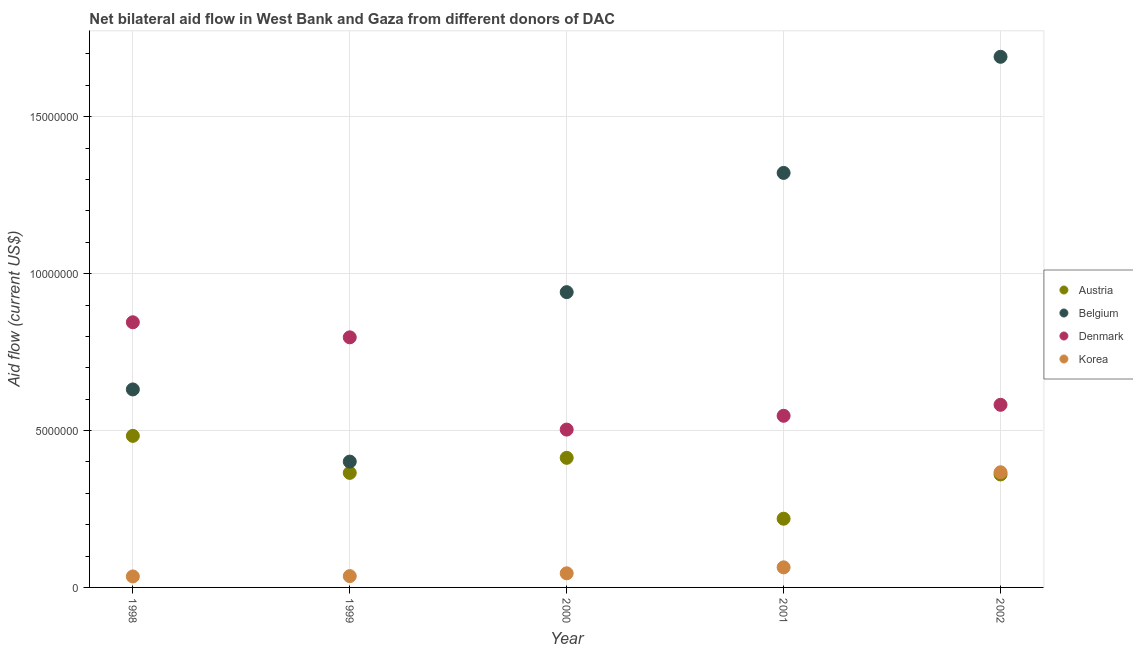How many different coloured dotlines are there?
Keep it short and to the point. 4. What is the amount of aid given by belgium in 2001?
Give a very brief answer. 1.32e+07. Across all years, what is the maximum amount of aid given by belgium?
Provide a short and direct response. 1.69e+07. Across all years, what is the minimum amount of aid given by belgium?
Keep it short and to the point. 4.01e+06. What is the total amount of aid given by korea in the graph?
Provide a succinct answer. 5.47e+06. What is the difference between the amount of aid given by austria in 2000 and that in 2001?
Give a very brief answer. 1.94e+06. What is the difference between the amount of aid given by denmark in 1998 and the amount of aid given by austria in 2000?
Your answer should be compact. 4.32e+06. What is the average amount of aid given by korea per year?
Make the answer very short. 1.09e+06. In the year 2001, what is the difference between the amount of aid given by denmark and amount of aid given by korea?
Your answer should be compact. 4.83e+06. What is the ratio of the amount of aid given by denmark in 2000 to that in 2002?
Ensure brevity in your answer.  0.86. Is the amount of aid given by denmark in 1998 less than that in 2001?
Offer a very short reply. No. What is the difference between the highest and the second highest amount of aid given by belgium?
Your answer should be very brief. 3.70e+06. What is the difference between the highest and the lowest amount of aid given by denmark?
Your answer should be compact. 3.42e+06. In how many years, is the amount of aid given by korea greater than the average amount of aid given by korea taken over all years?
Keep it short and to the point. 1. Is it the case that in every year, the sum of the amount of aid given by austria and amount of aid given by belgium is greater than the amount of aid given by denmark?
Offer a very short reply. No. Does the amount of aid given by denmark monotonically increase over the years?
Your response must be concise. No. Is the amount of aid given by austria strictly less than the amount of aid given by belgium over the years?
Offer a terse response. Yes. How many years are there in the graph?
Offer a terse response. 5. What is the difference between two consecutive major ticks on the Y-axis?
Provide a short and direct response. 5.00e+06. Are the values on the major ticks of Y-axis written in scientific E-notation?
Your answer should be very brief. No. Does the graph contain grids?
Your response must be concise. Yes. How are the legend labels stacked?
Offer a very short reply. Vertical. What is the title of the graph?
Your answer should be compact. Net bilateral aid flow in West Bank and Gaza from different donors of DAC. Does "Argument" appear as one of the legend labels in the graph?
Your answer should be compact. No. What is the Aid flow (current US$) of Austria in 1998?
Give a very brief answer. 4.83e+06. What is the Aid flow (current US$) of Belgium in 1998?
Your answer should be very brief. 6.31e+06. What is the Aid flow (current US$) of Denmark in 1998?
Keep it short and to the point. 8.45e+06. What is the Aid flow (current US$) in Korea in 1998?
Ensure brevity in your answer.  3.50e+05. What is the Aid flow (current US$) of Austria in 1999?
Your answer should be very brief. 3.65e+06. What is the Aid flow (current US$) in Belgium in 1999?
Provide a short and direct response. 4.01e+06. What is the Aid flow (current US$) of Denmark in 1999?
Your answer should be very brief. 7.97e+06. What is the Aid flow (current US$) of Korea in 1999?
Offer a terse response. 3.60e+05. What is the Aid flow (current US$) in Austria in 2000?
Keep it short and to the point. 4.13e+06. What is the Aid flow (current US$) in Belgium in 2000?
Offer a very short reply. 9.41e+06. What is the Aid flow (current US$) in Denmark in 2000?
Provide a succinct answer. 5.03e+06. What is the Aid flow (current US$) in Austria in 2001?
Keep it short and to the point. 2.19e+06. What is the Aid flow (current US$) of Belgium in 2001?
Give a very brief answer. 1.32e+07. What is the Aid flow (current US$) in Denmark in 2001?
Ensure brevity in your answer.  5.47e+06. What is the Aid flow (current US$) in Korea in 2001?
Your answer should be compact. 6.40e+05. What is the Aid flow (current US$) in Austria in 2002?
Make the answer very short. 3.60e+06. What is the Aid flow (current US$) in Belgium in 2002?
Your response must be concise. 1.69e+07. What is the Aid flow (current US$) of Denmark in 2002?
Your answer should be very brief. 5.82e+06. What is the Aid flow (current US$) of Korea in 2002?
Your answer should be compact. 3.67e+06. Across all years, what is the maximum Aid flow (current US$) of Austria?
Make the answer very short. 4.83e+06. Across all years, what is the maximum Aid flow (current US$) in Belgium?
Keep it short and to the point. 1.69e+07. Across all years, what is the maximum Aid flow (current US$) in Denmark?
Provide a short and direct response. 8.45e+06. Across all years, what is the maximum Aid flow (current US$) of Korea?
Keep it short and to the point. 3.67e+06. Across all years, what is the minimum Aid flow (current US$) in Austria?
Your response must be concise. 2.19e+06. Across all years, what is the minimum Aid flow (current US$) in Belgium?
Provide a short and direct response. 4.01e+06. Across all years, what is the minimum Aid flow (current US$) in Denmark?
Make the answer very short. 5.03e+06. What is the total Aid flow (current US$) in Austria in the graph?
Your answer should be very brief. 1.84e+07. What is the total Aid flow (current US$) of Belgium in the graph?
Your response must be concise. 4.98e+07. What is the total Aid flow (current US$) in Denmark in the graph?
Provide a succinct answer. 3.27e+07. What is the total Aid flow (current US$) in Korea in the graph?
Offer a terse response. 5.47e+06. What is the difference between the Aid flow (current US$) in Austria in 1998 and that in 1999?
Your response must be concise. 1.18e+06. What is the difference between the Aid flow (current US$) of Belgium in 1998 and that in 1999?
Your answer should be compact. 2.30e+06. What is the difference between the Aid flow (current US$) of Korea in 1998 and that in 1999?
Your answer should be compact. -10000. What is the difference between the Aid flow (current US$) in Belgium in 1998 and that in 2000?
Give a very brief answer. -3.10e+06. What is the difference between the Aid flow (current US$) of Denmark in 1998 and that in 2000?
Give a very brief answer. 3.42e+06. What is the difference between the Aid flow (current US$) of Korea in 1998 and that in 2000?
Your answer should be compact. -1.00e+05. What is the difference between the Aid flow (current US$) in Austria in 1998 and that in 2001?
Make the answer very short. 2.64e+06. What is the difference between the Aid flow (current US$) of Belgium in 1998 and that in 2001?
Offer a terse response. -6.90e+06. What is the difference between the Aid flow (current US$) of Denmark in 1998 and that in 2001?
Make the answer very short. 2.98e+06. What is the difference between the Aid flow (current US$) in Korea in 1998 and that in 2001?
Give a very brief answer. -2.90e+05. What is the difference between the Aid flow (current US$) of Austria in 1998 and that in 2002?
Offer a very short reply. 1.23e+06. What is the difference between the Aid flow (current US$) in Belgium in 1998 and that in 2002?
Your answer should be compact. -1.06e+07. What is the difference between the Aid flow (current US$) in Denmark in 1998 and that in 2002?
Keep it short and to the point. 2.63e+06. What is the difference between the Aid flow (current US$) in Korea in 1998 and that in 2002?
Your response must be concise. -3.32e+06. What is the difference between the Aid flow (current US$) of Austria in 1999 and that in 2000?
Your response must be concise. -4.80e+05. What is the difference between the Aid flow (current US$) in Belgium in 1999 and that in 2000?
Make the answer very short. -5.40e+06. What is the difference between the Aid flow (current US$) of Denmark in 1999 and that in 2000?
Your answer should be very brief. 2.94e+06. What is the difference between the Aid flow (current US$) in Austria in 1999 and that in 2001?
Make the answer very short. 1.46e+06. What is the difference between the Aid flow (current US$) of Belgium in 1999 and that in 2001?
Ensure brevity in your answer.  -9.20e+06. What is the difference between the Aid flow (current US$) in Denmark in 1999 and that in 2001?
Provide a short and direct response. 2.50e+06. What is the difference between the Aid flow (current US$) of Korea in 1999 and that in 2001?
Your answer should be very brief. -2.80e+05. What is the difference between the Aid flow (current US$) of Austria in 1999 and that in 2002?
Ensure brevity in your answer.  5.00e+04. What is the difference between the Aid flow (current US$) in Belgium in 1999 and that in 2002?
Your response must be concise. -1.29e+07. What is the difference between the Aid flow (current US$) of Denmark in 1999 and that in 2002?
Provide a succinct answer. 2.15e+06. What is the difference between the Aid flow (current US$) of Korea in 1999 and that in 2002?
Make the answer very short. -3.31e+06. What is the difference between the Aid flow (current US$) of Austria in 2000 and that in 2001?
Give a very brief answer. 1.94e+06. What is the difference between the Aid flow (current US$) of Belgium in 2000 and that in 2001?
Your answer should be very brief. -3.80e+06. What is the difference between the Aid flow (current US$) in Denmark in 2000 and that in 2001?
Give a very brief answer. -4.40e+05. What is the difference between the Aid flow (current US$) of Austria in 2000 and that in 2002?
Give a very brief answer. 5.30e+05. What is the difference between the Aid flow (current US$) in Belgium in 2000 and that in 2002?
Give a very brief answer. -7.50e+06. What is the difference between the Aid flow (current US$) in Denmark in 2000 and that in 2002?
Your answer should be compact. -7.90e+05. What is the difference between the Aid flow (current US$) in Korea in 2000 and that in 2002?
Your answer should be very brief. -3.22e+06. What is the difference between the Aid flow (current US$) in Austria in 2001 and that in 2002?
Give a very brief answer. -1.41e+06. What is the difference between the Aid flow (current US$) in Belgium in 2001 and that in 2002?
Your response must be concise. -3.70e+06. What is the difference between the Aid flow (current US$) of Denmark in 2001 and that in 2002?
Your answer should be very brief. -3.50e+05. What is the difference between the Aid flow (current US$) of Korea in 2001 and that in 2002?
Keep it short and to the point. -3.03e+06. What is the difference between the Aid flow (current US$) in Austria in 1998 and the Aid flow (current US$) in Belgium in 1999?
Ensure brevity in your answer.  8.20e+05. What is the difference between the Aid flow (current US$) in Austria in 1998 and the Aid flow (current US$) in Denmark in 1999?
Offer a terse response. -3.14e+06. What is the difference between the Aid flow (current US$) of Austria in 1998 and the Aid flow (current US$) of Korea in 1999?
Ensure brevity in your answer.  4.47e+06. What is the difference between the Aid flow (current US$) in Belgium in 1998 and the Aid flow (current US$) in Denmark in 1999?
Ensure brevity in your answer.  -1.66e+06. What is the difference between the Aid flow (current US$) in Belgium in 1998 and the Aid flow (current US$) in Korea in 1999?
Offer a very short reply. 5.95e+06. What is the difference between the Aid flow (current US$) in Denmark in 1998 and the Aid flow (current US$) in Korea in 1999?
Offer a terse response. 8.09e+06. What is the difference between the Aid flow (current US$) in Austria in 1998 and the Aid flow (current US$) in Belgium in 2000?
Give a very brief answer. -4.58e+06. What is the difference between the Aid flow (current US$) of Austria in 1998 and the Aid flow (current US$) of Korea in 2000?
Provide a short and direct response. 4.38e+06. What is the difference between the Aid flow (current US$) in Belgium in 1998 and the Aid flow (current US$) in Denmark in 2000?
Offer a very short reply. 1.28e+06. What is the difference between the Aid flow (current US$) in Belgium in 1998 and the Aid flow (current US$) in Korea in 2000?
Give a very brief answer. 5.86e+06. What is the difference between the Aid flow (current US$) in Denmark in 1998 and the Aid flow (current US$) in Korea in 2000?
Make the answer very short. 8.00e+06. What is the difference between the Aid flow (current US$) of Austria in 1998 and the Aid flow (current US$) of Belgium in 2001?
Your answer should be very brief. -8.38e+06. What is the difference between the Aid flow (current US$) in Austria in 1998 and the Aid flow (current US$) in Denmark in 2001?
Your response must be concise. -6.40e+05. What is the difference between the Aid flow (current US$) in Austria in 1998 and the Aid flow (current US$) in Korea in 2001?
Make the answer very short. 4.19e+06. What is the difference between the Aid flow (current US$) of Belgium in 1998 and the Aid flow (current US$) of Denmark in 2001?
Your answer should be compact. 8.40e+05. What is the difference between the Aid flow (current US$) of Belgium in 1998 and the Aid flow (current US$) of Korea in 2001?
Your answer should be very brief. 5.67e+06. What is the difference between the Aid flow (current US$) in Denmark in 1998 and the Aid flow (current US$) in Korea in 2001?
Give a very brief answer. 7.81e+06. What is the difference between the Aid flow (current US$) of Austria in 1998 and the Aid flow (current US$) of Belgium in 2002?
Provide a succinct answer. -1.21e+07. What is the difference between the Aid flow (current US$) of Austria in 1998 and the Aid flow (current US$) of Denmark in 2002?
Offer a very short reply. -9.90e+05. What is the difference between the Aid flow (current US$) of Austria in 1998 and the Aid flow (current US$) of Korea in 2002?
Keep it short and to the point. 1.16e+06. What is the difference between the Aid flow (current US$) in Belgium in 1998 and the Aid flow (current US$) in Korea in 2002?
Your answer should be compact. 2.64e+06. What is the difference between the Aid flow (current US$) of Denmark in 1998 and the Aid flow (current US$) of Korea in 2002?
Your answer should be very brief. 4.78e+06. What is the difference between the Aid flow (current US$) of Austria in 1999 and the Aid flow (current US$) of Belgium in 2000?
Give a very brief answer. -5.76e+06. What is the difference between the Aid flow (current US$) of Austria in 1999 and the Aid flow (current US$) of Denmark in 2000?
Keep it short and to the point. -1.38e+06. What is the difference between the Aid flow (current US$) of Austria in 1999 and the Aid flow (current US$) of Korea in 2000?
Your answer should be very brief. 3.20e+06. What is the difference between the Aid flow (current US$) of Belgium in 1999 and the Aid flow (current US$) of Denmark in 2000?
Offer a terse response. -1.02e+06. What is the difference between the Aid flow (current US$) in Belgium in 1999 and the Aid flow (current US$) in Korea in 2000?
Keep it short and to the point. 3.56e+06. What is the difference between the Aid flow (current US$) in Denmark in 1999 and the Aid flow (current US$) in Korea in 2000?
Ensure brevity in your answer.  7.52e+06. What is the difference between the Aid flow (current US$) of Austria in 1999 and the Aid flow (current US$) of Belgium in 2001?
Provide a succinct answer. -9.56e+06. What is the difference between the Aid flow (current US$) in Austria in 1999 and the Aid flow (current US$) in Denmark in 2001?
Give a very brief answer. -1.82e+06. What is the difference between the Aid flow (current US$) in Austria in 1999 and the Aid flow (current US$) in Korea in 2001?
Your response must be concise. 3.01e+06. What is the difference between the Aid flow (current US$) in Belgium in 1999 and the Aid flow (current US$) in Denmark in 2001?
Keep it short and to the point. -1.46e+06. What is the difference between the Aid flow (current US$) in Belgium in 1999 and the Aid flow (current US$) in Korea in 2001?
Ensure brevity in your answer.  3.37e+06. What is the difference between the Aid flow (current US$) in Denmark in 1999 and the Aid flow (current US$) in Korea in 2001?
Ensure brevity in your answer.  7.33e+06. What is the difference between the Aid flow (current US$) of Austria in 1999 and the Aid flow (current US$) of Belgium in 2002?
Give a very brief answer. -1.33e+07. What is the difference between the Aid flow (current US$) of Austria in 1999 and the Aid flow (current US$) of Denmark in 2002?
Your response must be concise. -2.17e+06. What is the difference between the Aid flow (current US$) in Austria in 1999 and the Aid flow (current US$) in Korea in 2002?
Provide a succinct answer. -2.00e+04. What is the difference between the Aid flow (current US$) of Belgium in 1999 and the Aid flow (current US$) of Denmark in 2002?
Keep it short and to the point. -1.81e+06. What is the difference between the Aid flow (current US$) in Denmark in 1999 and the Aid flow (current US$) in Korea in 2002?
Give a very brief answer. 4.30e+06. What is the difference between the Aid flow (current US$) in Austria in 2000 and the Aid flow (current US$) in Belgium in 2001?
Ensure brevity in your answer.  -9.08e+06. What is the difference between the Aid flow (current US$) in Austria in 2000 and the Aid flow (current US$) in Denmark in 2001?
Your response must be concise. -1.34e+06. What is the difference between the Aid flow (current US$) in Austria in 2000 and the Aid flow (current US$) in Korea in 2001?
Give a very brief answer. 3.49e+06. What is the difference between the Aid flow (current US$) of Belgium in 2000 and the Aid flow (current US$) of Denmark in 2001?
Make the answer very short. 3.94e+06. What is the difference between the Aid flow (current US$) of Belgium in 2000 and the Aid flow (current US$) of Korea in 2001?
Keep it short and to the point. 8.77e+06. What is the difference between the Aid flow (current US$) of Denmark in 2000 and the Aid flow (current US$) of Korea in 2001?
Make the answer very short. 4.39e+06. What is the difference between the Aid flow (current US$) in Austria in 2000 and the Aid flow (current US$) in Belgium in 2002?
Make the answer very short. -1.28e+07. What is the difference between the Aid flow (current US$) of Austria in 2000 and the Aid flow (current US$) of Denmark in 2002?
Your answer should be very brief. -1.69e+06. What is the difference between the Aid flow (current US$) of Austria in 2000 and the Aid flow (current US$) of Korea in 2002?
Your answer should be compact. 4.60e+05. What is the difference between the Aid flow (current US$) in Belgium in 2000 and the Aid flow (current US$) in Denmark in 2002?
Provide a succinct answer. 3.59e+06. What is the difference between the Aid flow (current US$) of Belgium in 2000 and the Aid flow (current US$) of Korea in 2002?
Provide a short and direct response. 5.74e+06. What is the difference between the Aid flow (current US$) in Denmark in 2000 and the Aid flow (current US$) in Korea in 2002?
Make the answer very short. 1.36e+06. What is the difference between the Aid flow (current US$) in Austria in 2001 and the Aid flow (current US$) in Belgium in 2002?
Your answer should be very brief. -1.47e+07. What is the difference between the Aid flow (current US$) of Austria in 2001 and the Aid flow (current US$) of Denmark in 2002?
Offer a terse response. -3.63e+06. What is the difference between the Aid flow (current US$) of Austria in 2001 and the Aid flow (current US$) of Korea in 2002?
Provide a succinct answer. -1.48e+06. What is the difference between the Aid flow (current US$) in Belgium in 2001 and the Aid flow (current US$) in Denmark in 2002?
Make the answer very short. 7.39e+06. What is the difference between the Aid flow (current US$) of Belgium in 2001 and the Aid flow (current US$) of Korea in 2002?
Your answer should be very brief. 9.54e+06. What is the difference between the Aid flow (current US$) in Denmark in 2001 and the Aid flow (current US$) in Korea in 2002?
Make the answer very short. 1.80e+06. What is the average Aid flow (current US$) of Austria per year?
Your answer should be very brief. 3.68e+06. What is the average Aid flow (current US$) of Belgium per year?
Your answer should be very brief. 9.97e+06. What is the average Aid flow (current US$) of Denmark per year?
Your answer should be compact. 6.55e+06. What is the average Aid flow (current US$) of Korea per year?
Offer a terse response. 1.09e+06. In the year 1998, what is the difference between the Aid flow (current US$) of Austria and Aid flow (current US$) of Belgium?
Your answer should be very brief. -1.48e+06. In the year 1998, what is the difference between the Aid flow (current US$) in Austria and Aid flow (current US$) in Denmark?
Offer a very short reply. -3.62e+06. In the year 1998, what is the difference between the Aid flow (current US$) in Austria and Aid flow (current US$) in Korea?
Make the answer very short. 4.48e+06. In the year 1998, what is the difference between the Aid flow (current US$) of Belgium and Aid flow (current US$) of Denmark?
Provide a succinct answer. -2.14e+06. In the year 1998, what is the difference between the Aid flow (current US$) of Belgium and Aid flow (current US$) of Korea?
Ensure brevity in your answer.  5.96e+06. In the year 1998, what is the difference between the Aid flow (current US$) in Denmark and Aid flow (current US$) in Korea?
Ensure brevity in your answer.  8.10e+06. In the year 1999, what is the difference between the Aid flow (current US$) in Austria and Aid flow (current US$) in Belgium?
Offer a very short reply. -3.60e+05. In the year 1999, what is the difference between the Aid flow (current US$) in Austria and Aid flow (current US$) in Denmark?
Give a very brief answer. -4.32e+06. In the year 1999, what is the difference between the Aid flow (current US$) in Austria and Aid flow (current US$) in Korea?
Make the answer very short. 3.29e+06. In the year 1999, what is the difference between the Aid flow (current US$) in Belgium and Aid flow (current US$) in Denmark?
Ensure brevity in your answer.  -3.96e+06. In the year 1999, what is the difference between the Aid flow (current US$) in Belgium and Aid flow (current US$) in Korea?
Your answer should be compact. 3.65e+06. In the year 1999, what is the difference between the Aid flow (current US$) of Denmark and Aid flow (current US$) of Korea?
Ensure brevity in your answer.  7.61e+06. In the year 2000, what is the difference between the Aid flow (current US$) of Austria and Aid flow (current US$) of Belgium?
Ensure brevity in your answer.  -5.28e+06. In the year 2000, what is the difference between the Aid flow (current US$) in Austria and Aid flow (current US$) in Denmark?
Provide a short and direct response. -9.00e+05. In the year 2000, what is the difference between the Aid flow (current US$) of Austria and Aid flow (current US$) of Korea?
Ensure brevity in your answer.  3.68e+06. In the year 2000, what is the difference between the Aid flow (current US$) in Belgium and Aid flow (current US$) in Denmark?
Provide a short and direct response. 4.38e+06. In the year 2000, what is the difference between the Aid flow (current US$) of Belgium and Aid flow (current US$) of Korea?
Keep it short and to the point. 8.96e+06. In the year 2000, what is the difference between the Aid flow (current US$) in Denmark and Aid flow (current US$) in Korea?
Make the answer very short. 4.58e+06. In the year 2001, what is the difference between the Aid flow (current US$) in Austria and Aid flow (current US$) in Belgium?
Give a very brief answer. -1.10e+07. In the year 2001, what is the difference between the Aid flow (current US$) of Austria and Aid flow (current US$) of Denmark?
Your response must be concise. -3.28e+06. In the year 2001, what is the difference between the Aid flow (current US$) in Austria and Aid flow (current US$) in Korea?
Provide a succinct answer. 1.55e+06. In the year 2001, what is the difference between the Aid flow (current US$) of Belgium and Aid flow (current US$) of Denmark?
Offer a very short reply. 7.74e+06. In the year 2001, what is the difference between the Aid flow (current US$) of Belgium and Aid flow (current US$) of Korea?
Offer a terse response. 1.26e+07. In the year 2001, what is the difference between the Aid flow (current US$) of Denmark and Aid flow (current US$) of Korea?
Your answer should be compact. 4.83e+06. In the year 2002, what is the difference between the Aid flow (current US$) in Austria and Aid flow (current US$) in Belgium?
Keep it short and to the point. -1.33e+07. In the year 2002, what is the difference between the Aid flow (current US$) of Austria and Aid flow (current US$) of Denmark?
Offer a terse response. -2.22e+06. In the year 2002, what is the difference between the Aid flow (current US$) in Austria and Aid flow (current US$) in Korea?
Your response must be concise. -7.00e+04. In the year 2002, what is the difference between the Aid flow (current US$) in Belgium and Aid flow (current US$) in Denmark?
Offer a terse response. 1.11e+07. In the year 2002, what is the difference between the Aid flow (current US$) of Belgium and Aid flow (current US$) of Korea?
Provide a short and direct response. 1.32e+07. In the year 2002, what is the difference between the Aid flow (current US$) of Denmark and Aid flow (current US$) of Korea?
Your response must be concise. 2.15e+06. What is the ratio of the Aid flow (current US$) of Austria in 1998 to that in 1999?
Your response must be concise. 1.32. What is the ratio of the Aid flow (current US$) in Belgium in 1998 to that in 1999?
Your response must be concise. 1.57. What is the ratio of the Aid flow (current US$) of Denmark in 1998 to that in 1999?
Provide a short and direct response. 1.06. What is the ratio of the Aid flow (current US$) in Korea in 1998 to that in 1999?
Your response must be concise. 0.97. What is the ratio of the Aid flow (current US$) in Austria in 1998 to that in 2000?
Your answer should be very brief. 1.17. What is the ratio of the Aid flow (current US$) in Belgium in 1998 to that in 2000?
Your response must be concise. 0.67. What is the ratio of the Aid flow (current US$) of Denmark in 1998 to that in 2000?
Provide a short and direct response. 1.68. What is the ratio of the Aid flow (current US$) of Austria in 1998 to that in 2001?
Your response must be concise. 2.21. What is the ratio of the Aid flow (current US$) of Belgium in 1998 to that in 2001?
Offer a very short reply. 0.48. What is the ratio of the Aid flow (current US$) in Denmark in 1998 to that in 2001?
Ensure brevity in your answer.  1.54. What is the ratio of the Aid flow (current US$) of Korea in 1998 to that in 2001?
Ensure brevity in your answer.  0.55. What is the ratio of the Aid flow (current US$) in Austria in 1998 to that in 2002?
Offer a terse response. 1.34. What is the ratio of the Aid flow (current US$) in Belgium in 1998 to that in 2002?
Give a very brief answer. 0.37. What is the ratio of the Aid flow (current US$) in Denmark in 1998 to that in 2002?
Give a very brief answer. 1.45. What is the ratio of the Aid flow (current US$) in Korea in 1998 to that in 2002?
Provide a short and direct response. 0.1. What is the ratio of the Aid flow (current US$) of Austria in 1999 to that in 2000?
Offer a very short reply. 0.88. What is the ratio of the Aid flow (current US$) of Belgium in 1999 to that in 2000?
Offer a very short reply. 0.43. What is the ratio of the Aid flow (current US$) of Denmark in 1999 to that in 2000?
Your answer should be very brief. 1.58. What is the ratio of the Aid flow (current US$) in Belgium in 1999 to that in 2001?
Your answer should be compact. 0.3. What is the ratio of the Aid flow (current US$) of Denmark in 1999 to that in 2001?
Your answer should be very brief. 1.46. What is the ratio of the Aid flow (current US$) in Korea in 1999 to that in 2001?
Provide a succinct answer. 0.56. What is the ratio of the Aid flow (current US$) in Austria in 1999 to that in 2002?
Your answer should be compact. 1.01. What is the ratio of the Aid flow (current US$) of Belgium in 1999 to that in 2002?
Ensure brevity in your answer.  0.24. What is the ratio of the Aid flow (current US$) of Denmark in 1999 to that in 2002?
Keep it short and to the point. 1.37. What is the ratio of the Aid flow (current US$) of Korea in 1999 to that in 2002?
Provide a short and direct response. 0.1. What is the ratio of the Aid flow (current US$) in Austria in 2000 to that in 2001?
Give a very brief answer. 1.89. What is the ratio of the Aid flow (current US$) in Belgium in 2000 to that in 2001?
Ensure brevity in your answer.  0.71. What is the ratio of the Aid flow (current US$) of Denmark in 2000 to that in 2001?
Your answer should be compact. 0.92. What is the ratio of the Aid flow (current US$) of Korea in 2000 to that in 2001?
Provide a short and direct response. 0.7. What is the ratio of the Aid flow (current US$) of Austria in 2000 to that in 2002?
Provide a short and direct response. 1.15. What is the ratio of the Aid flow (current US$) in Belgium in 2000 to that in 2002?
Your answer should be very brief. 0.56. What is the ratio of the Aid flow (current US$) in Denmark in 2000 to that in 2002?
Give a very brief answer. 0.86. What is the ratio of the Aid flow (current US$) of Korea in 2000 to that in 2002?
Keep it short and to the point. 0.12. What is the ratio of the Aid flow (current US$) of Austria in 2001 to that in 2002?
Make the answer very short. 0.61. What is the ratio of the Aid flow (current US$) of Belgium in 2001 to that in 2002?
Keep it short and to the point. 0.78. What is the ratio of the Aid flow (current US$) of Denmark in 2001 to that in 2002?
Give a very brief answer. 0.94. What is the ratio of the Aid flow (current US$) in Korea in 2001 to that in 2002?
Your response must be concise. 0.17. What is the difference between the highest and the second highest Aid flow (current US$) of Austria?
Your answer should be very brief. 7.00e+05. What is the difference between the highest and the second highest Aid flow (current US$) of Belgium?
Ensure brevity in your answer.  3.70e+06. What is the difference between the highest and the second highest Aid flow (current US$) in Korea?
Ensure brevity in your answer.  3.03e+06. What is the difference between the highest and the lowest Aid flow (current US$) in Austria?
Provide a short and direct response. 2.64e+06. What is the difference between the highest and the lowest Aid flow (current US$) in Belgium?
Make the answer very short. 1.29e+07. What is the difference between the highest and the lowest Aid flow (current US$) in Denmark?
Your response must be concise. 3.42e+06. What is the difference between the highest and the lowest Aid flow (current US$) in Korea?
Ensure brevity in your answer.  3.32e+06. 